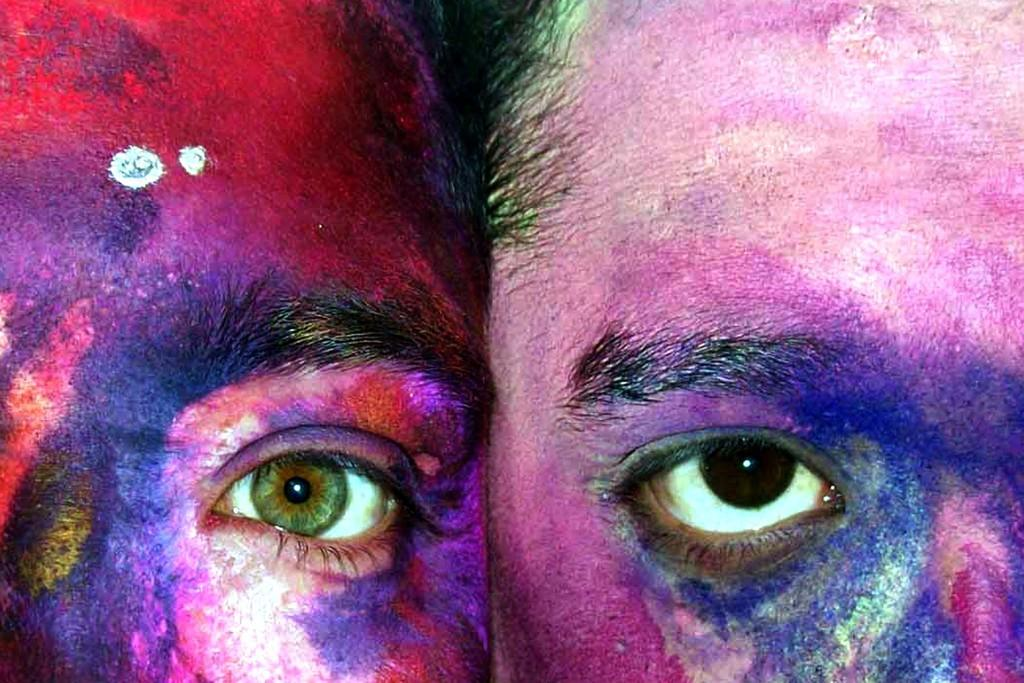What is present on both sides of the image? There are two colored faces in the image, one on the right side and the other on the left side. Can you describe the positioning of the faces in the image? One face is on the right side of the image, and the other face is on the left side of the image. What type of paste is being used to cook the faces in the image? There is no paste or cooking activity present in the image; it features two colored faces. What type of plane is visible in the image? There is no plane present in the image. 